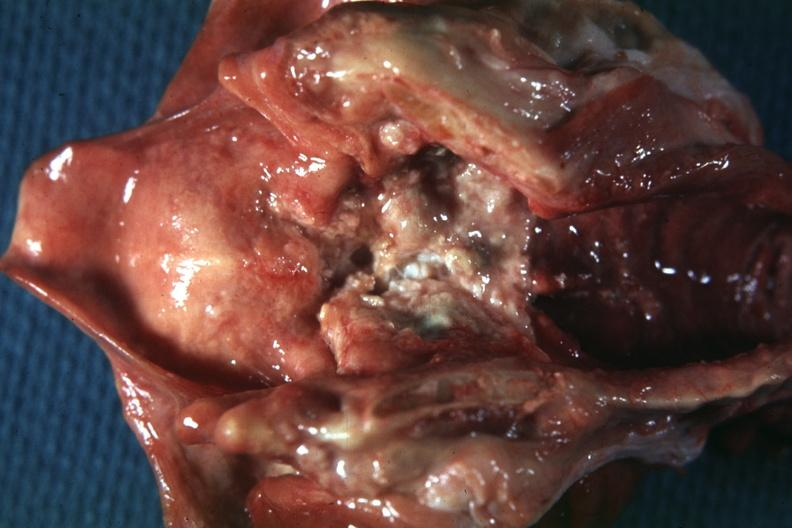does periprostatic vein thrombi show excellent very large ulcerative lesion?
Answer the question using a single word or phrase. No 